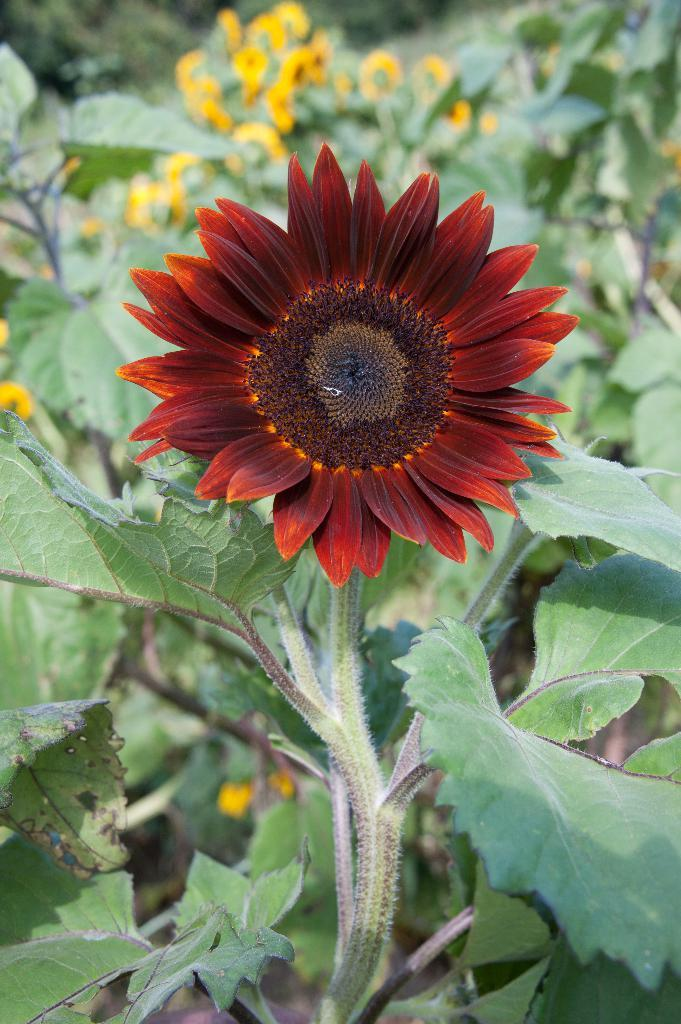What type of plants can be seen in the image? There are plants with flowers in the image. Can you describe the background of the image? The background of the image is blurred. What type of knowledge can be gained from the horse in the image? There is no horse present in the image, so no knowledge can be gained from a horse. How many light bulbs are visible in the image? There are no light bulbs visible in the image; it features plants with flowers and a blurred background. 